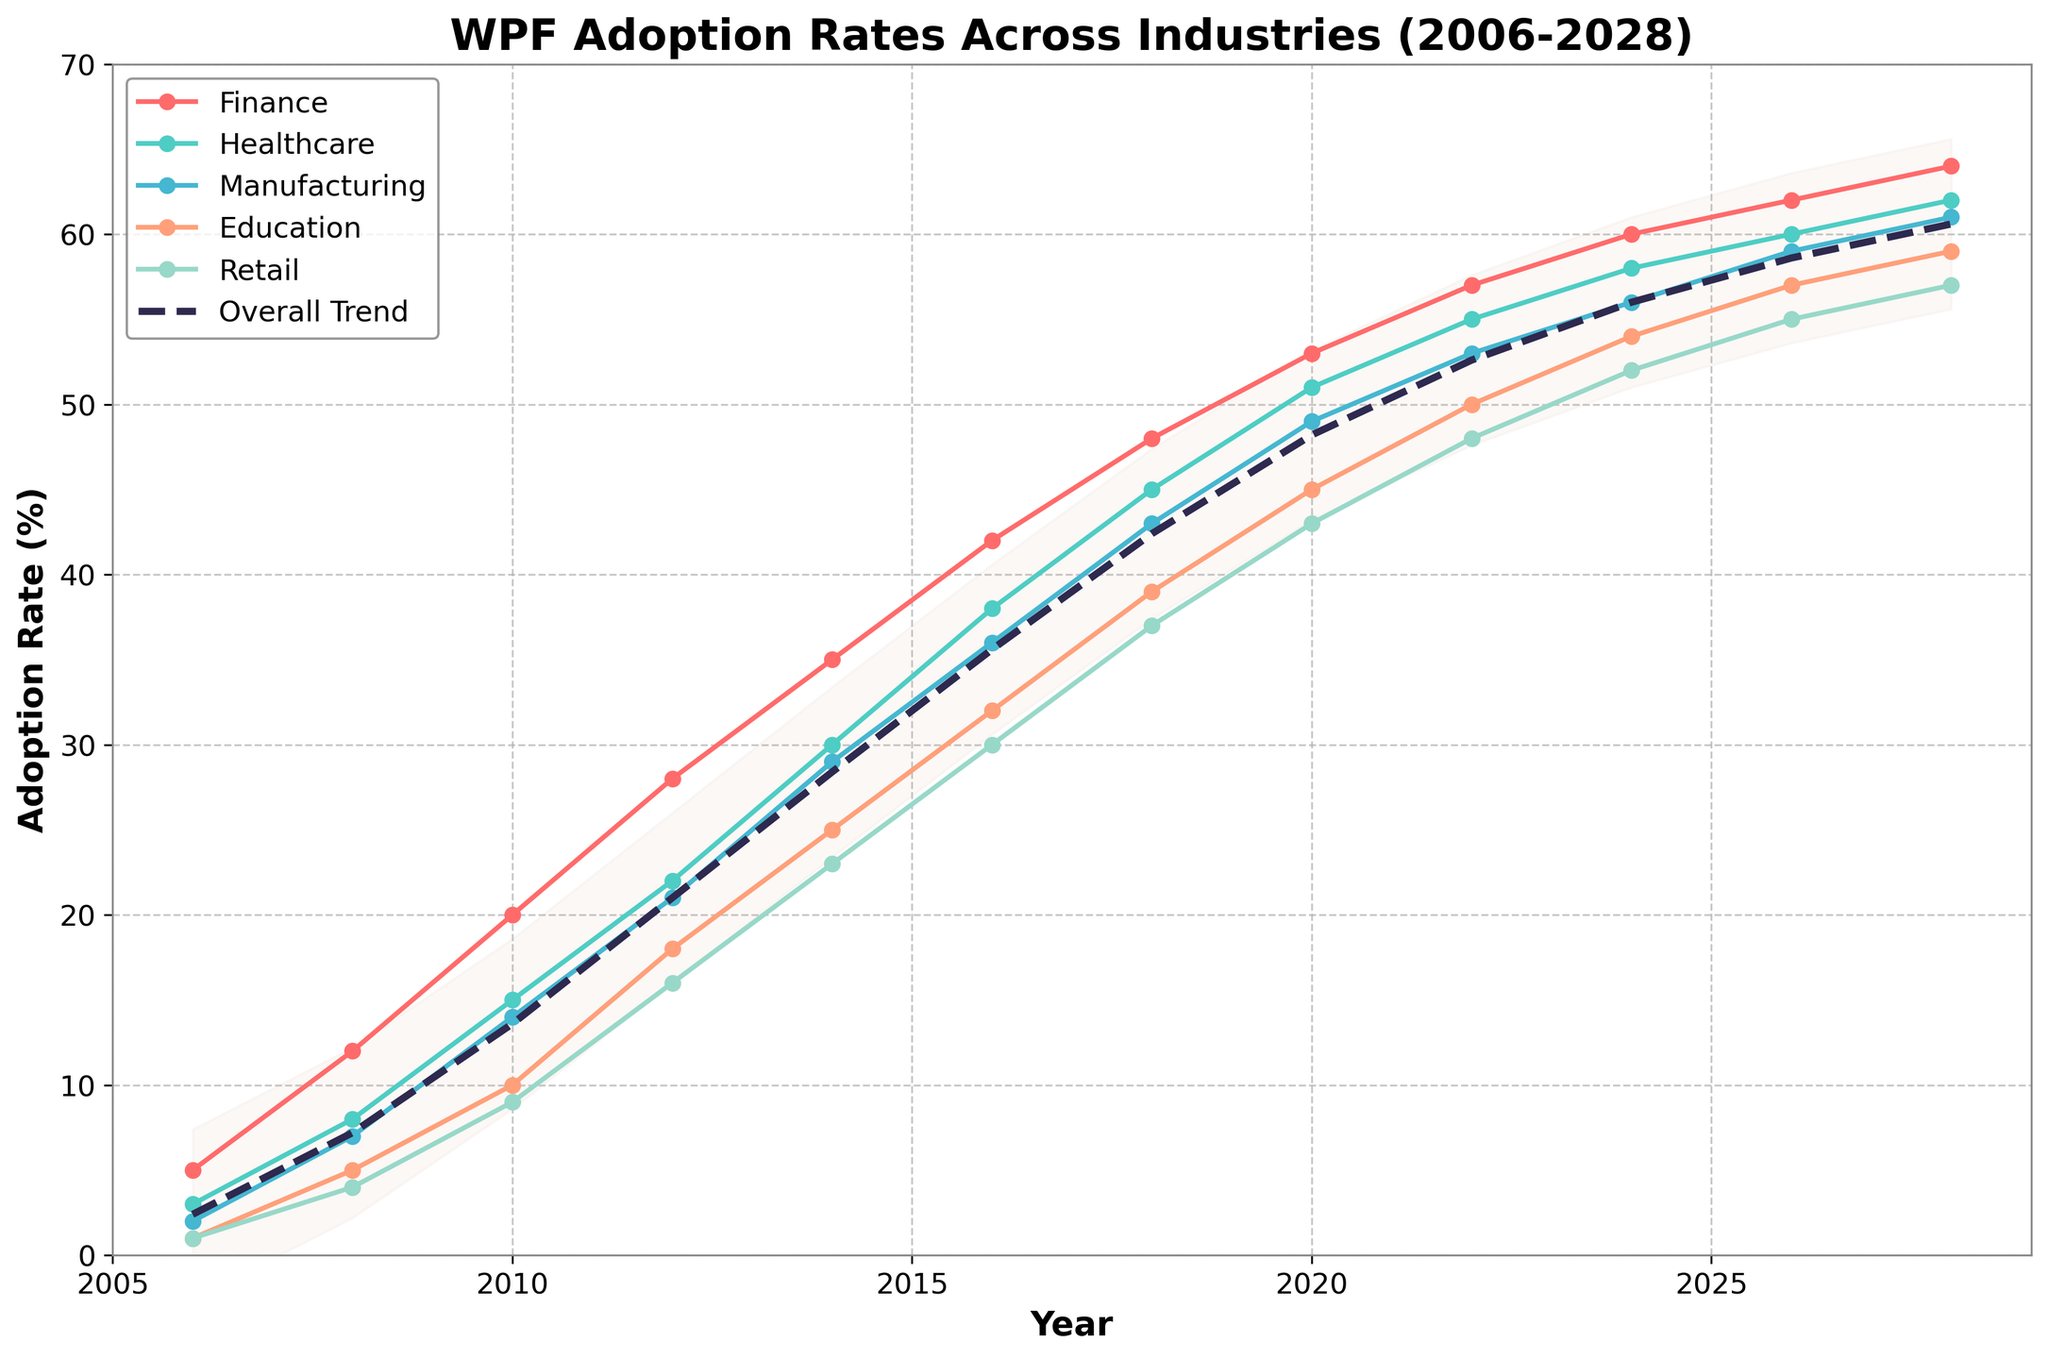What's the title of the chart? The title of the chart is visibly located at the top and reads "WPF Adoption Rates Across Industries (2006-2028)".
Answer: WPF Adoption Rates Across Industries (2006-2028) What is the overall adoption rate in 2020? Find the year 2020 on the x-axis and check the dashed line labeled "Overall Trend". The y-value for 2020 is 48.2.
Answer: 48.2 How does the adoption rate in Finance in 2012 compare to that in Healthcare in the same year? Locate the year 2012 on the x-axis, find the points for Finance and Healthcare. The Finance adoption rate is 28, while Healthcare is 22, so Finance is higher.
Answer: Finance is higher Which industry is forecasted to have the highest adoption rate in 2028? Move to the year 2028 on the x-axis and compare the plotted points for all industries. The Finance industry shows the highest adoption rate at this year.
Answer: Finance What is the difference in adoption rates between the Education and Retail industries in 2016? For the year 2016, locate the points for Education and Retail. Education is at 32 and Retail is 30. Subtracting 30 from 32 gives a difference of 2.
Answer: 2 What is the approximate trend range for the overall adoption rates over the years? Look at the filled area around the "Overall Trend" line. The area usually spans from the overall rate minus 5 to the overall rate plus 5 over the years.
Answer: Overall ± 5 Between which years did the Healthcare industry see its largest increase in adoption rate? Compare the year-to-year differences in Healthcare from the figure. The largest increase appears between 2006 and 2008 when the rate went from 3 to 8.
Answer: 2006-2008 Which industry shows the most consistent growth in adoption rates over the years? Compare the slope patterns of plotted lines for each industry. Healthcare shows a consistent upward trend without sharp changes.
Answer: Healthcare In which year did the Manufacturing industry reach an adoption rate of 21%? Follow the series line for Manufacturing and locate the year when its adoption rate reaches 21%. It reached in 2012.
Answer: 2012 